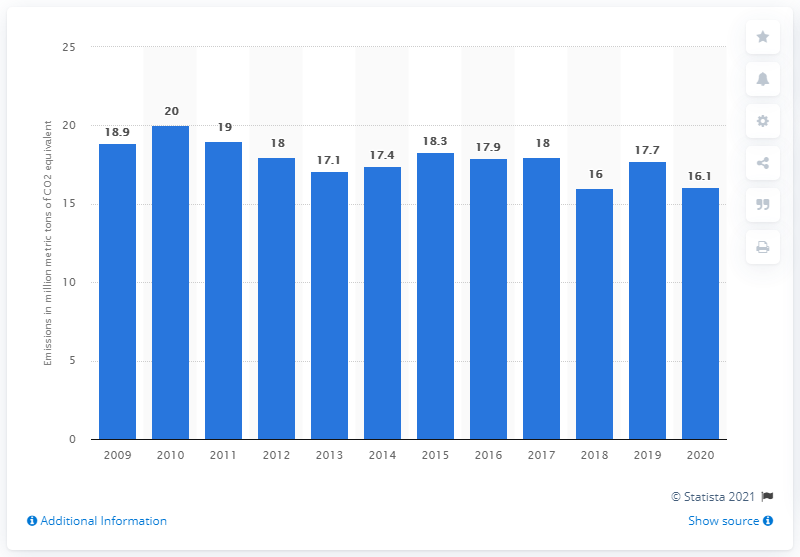Mention a couple of crucial points in this snapshot. In 2010, Anglo American emitted a significant amount of carbon dioxide equivalent, which is a measure of the greenhouse gas emissions caused by the company's operations. According to our records, by the end of 2020, AngloAmerican had emitted a total of 16.1 gigatons of carbon dioxide equivalent. 